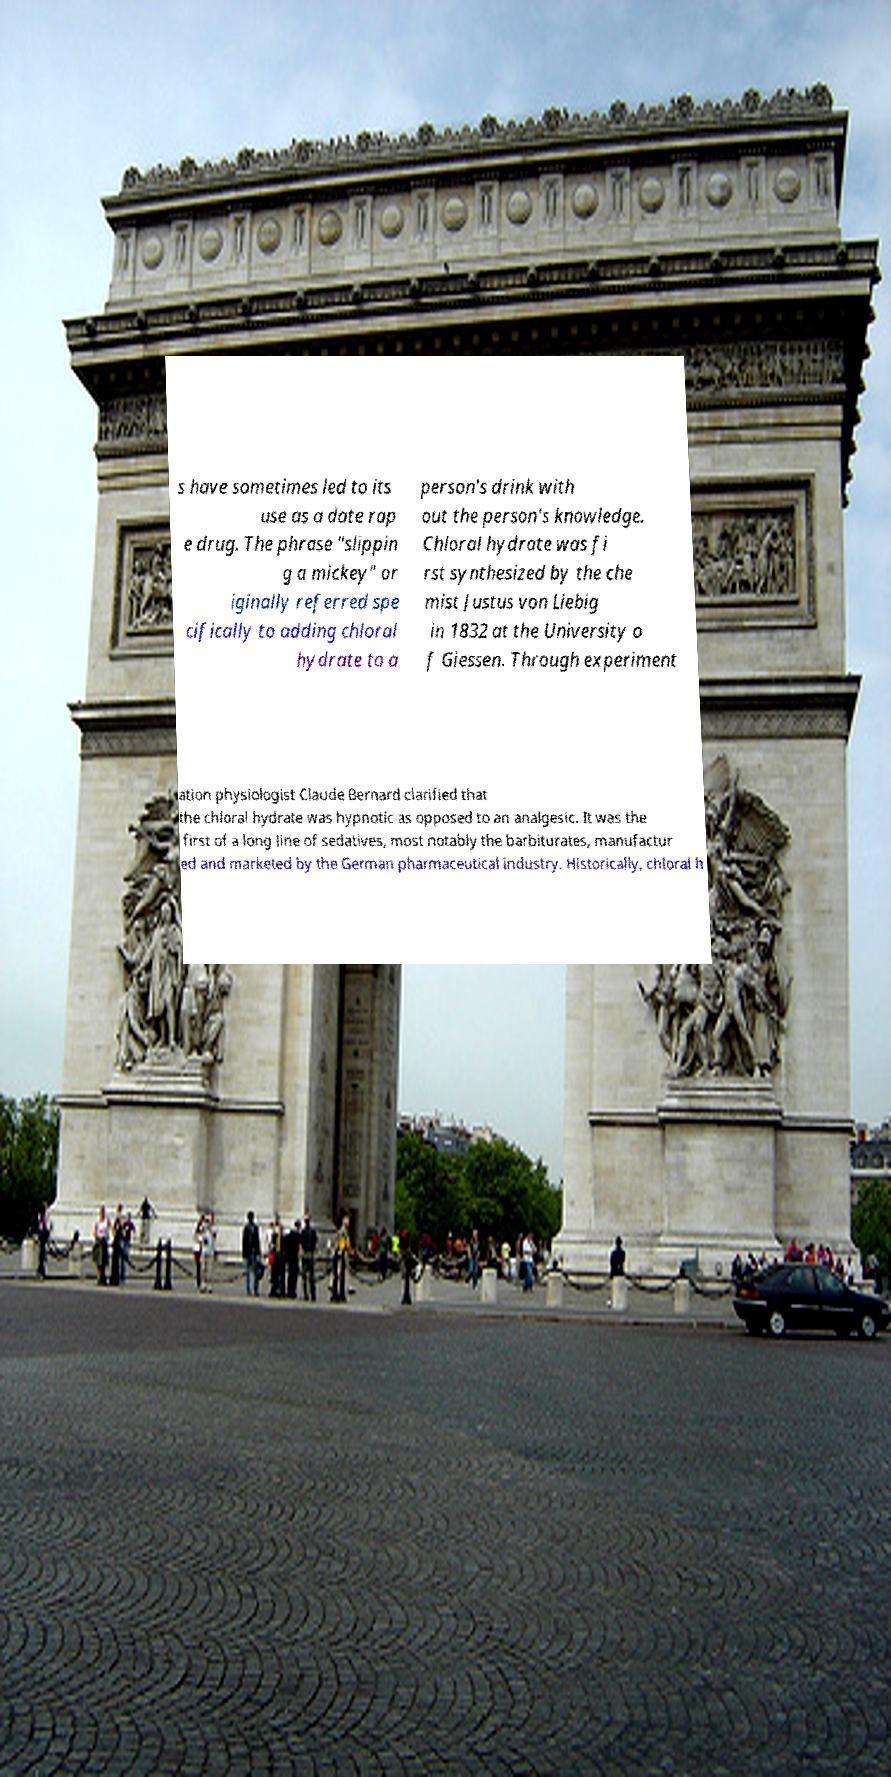I need the written content from this picture converted into text. Can you do that? s have sometimes led to its use as a date rap e drug. The phrase "slippin g a mickey" or iginally referred spe cifically to adding chloral hydrate to a person's drink with out the person's knowledge. Chloral hydrate was fi rst synthesized by the che mist Justus von Liebig in 1832 at the University o f Giessen. Through experiment ation physiologist Claude Bernard clarified that the chloral hydrate was hypnotic as opposed to an analgesic. It was the first of a long line of sedatives, most notably the barbiturates, manufactur ed and marketed by the German pharmaceutical industry. Historically, chloral h 